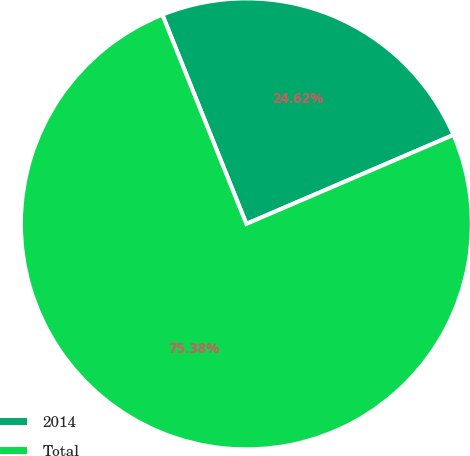<chart> <loc_0><loc_0><loc_500><loc_500><pie_chart><fcel>2014<fcel>Total<nl><fcel>24.62%<fcel>75.38%<nl></chart> 